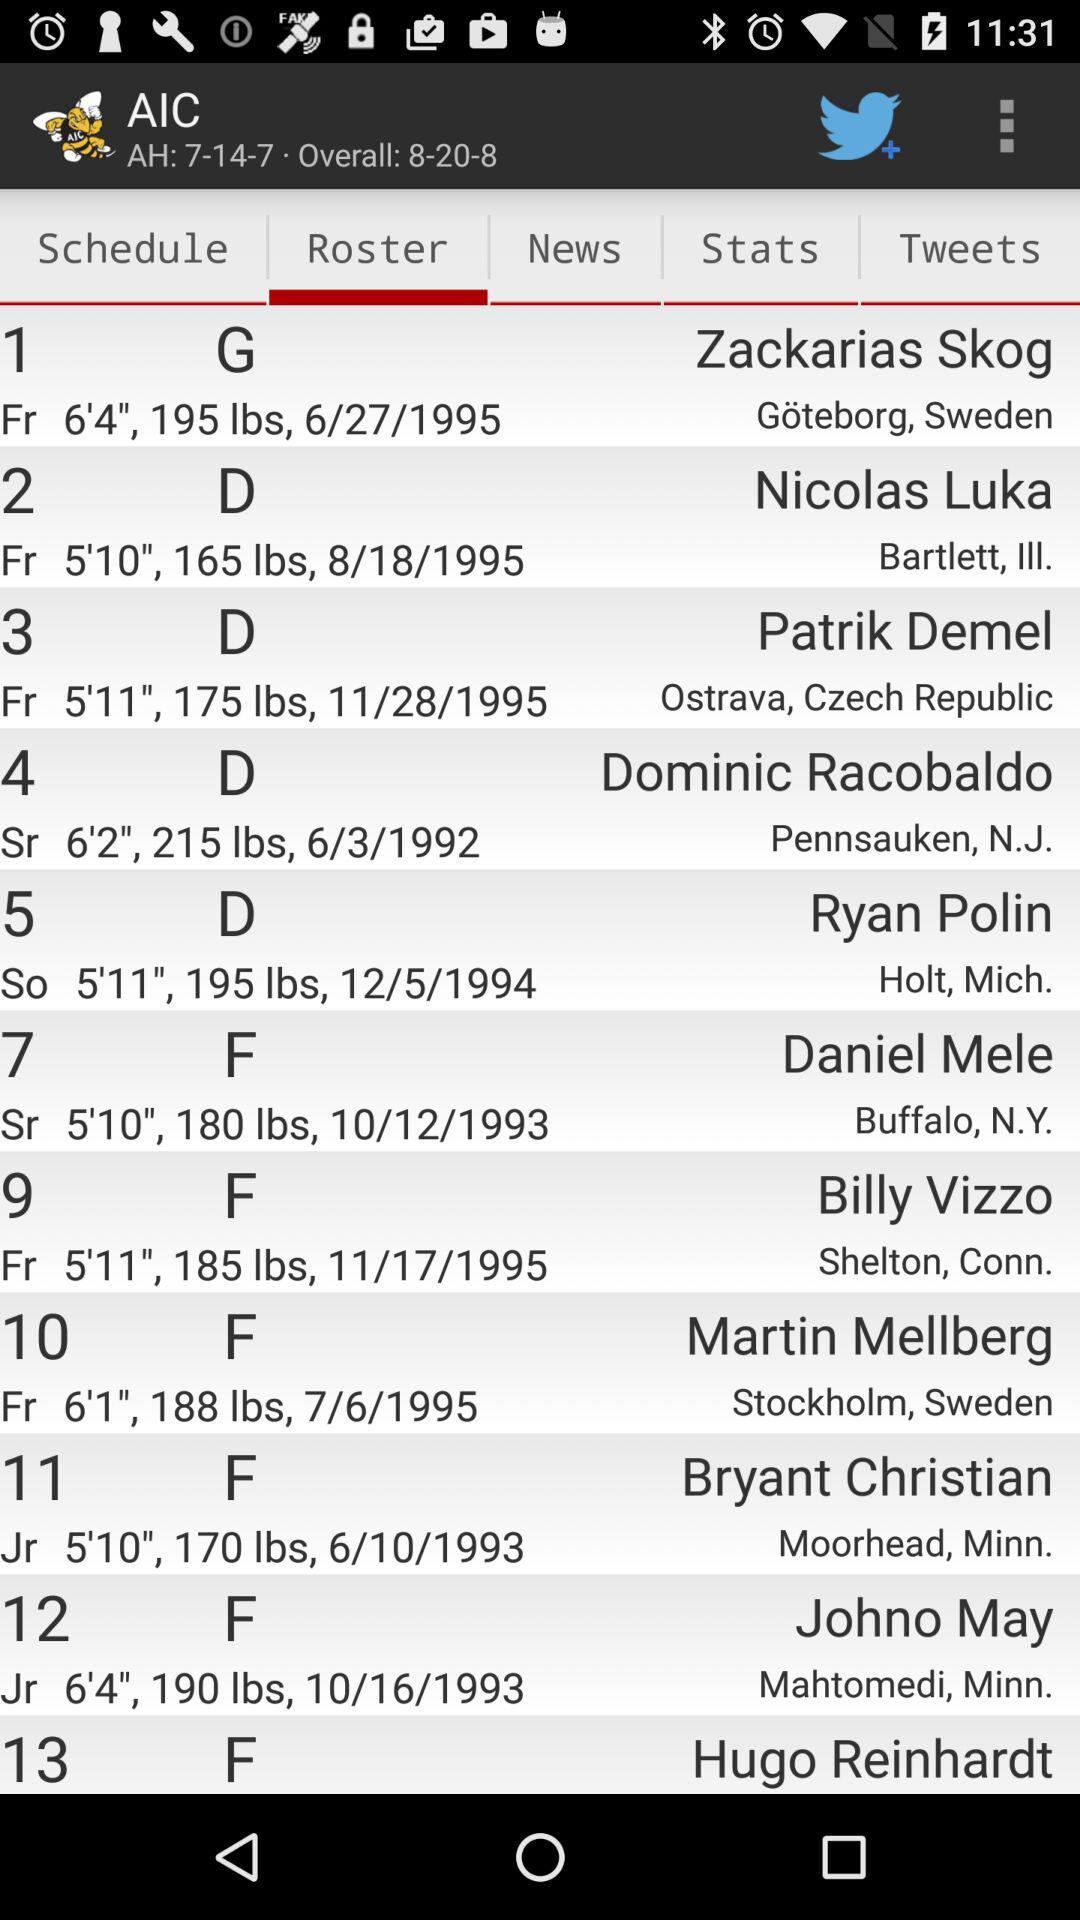How many players are on the AIC hockey roster?
Answer the question using a single word or phrase. 13 